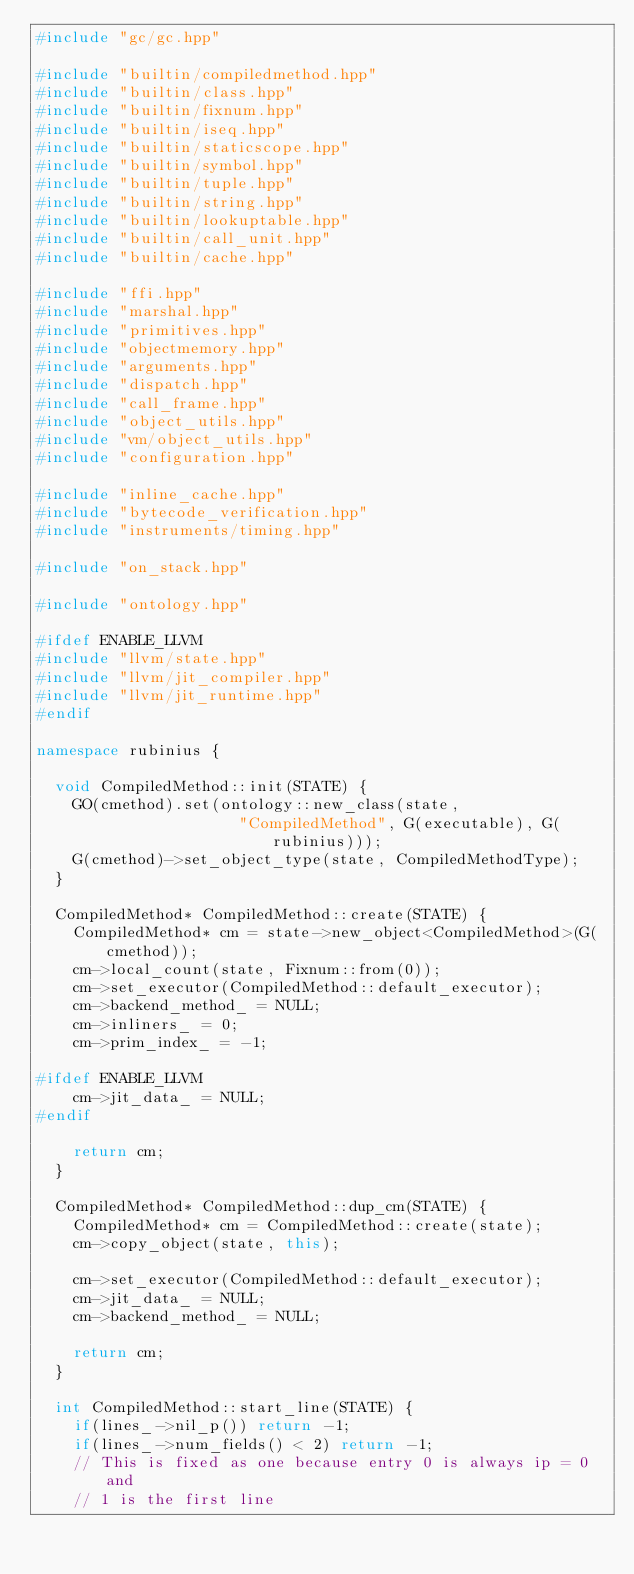<code> <loc_0><loc_0><loc_500><loc_500><_C++_>#include "gc/gc.hpp"

#include "builtin/compiledmethod.hpp"
#include "builtin/class.hpp"
#include "builtin/fixnum.hpp"
#include "builtin/iseq.hpp"
#include "builtin/staticscope.hpp"
#include "builtin/symbol.hpp"
#include "builtin/tuple.hpp"
#include "builtin/string.hpp"
#include "builtin/lookuptable.hpp"
#include "builtin/call_unit.hpp"
#include "builtin/cache.hpp"

#include "ffi.hpp"
#include "marshal.hpp"
#include "primitives.hpp"
#include "objectmemory.hpp"
#include "arguments.hpp"
#include "dispatch.hpp"
#include "call_frame.hpp"
#include "object_utils.hpp"
#include "vm/object_utils.hpp"
#include "configuration.hpp"

#include "inline_cache.hpp"
#include "bytecode_verification.hpp"
#include "instruments/timing.hpp"

#include "on_stack.hpp"

#include "ontology.hpp"

#ifdef ENABLE_LLVM
#include "llvm/state.hpp"
#include "llvm/jit_compiler.hpp"
#include "llvm/jit_runtime.hpp"
#endif

namespace rubinius {

  void CompiledMethod::init(STATE) {
    GO(cmethod).set(ontology::new_class(state,
                      "CompiledMethod", G(executable), G(rubinius)));
    G(cmethod)->set_object_type(state, CompiledMethodType);
  }

  CompiledMethod* CompiledMethod::create(STATE) {
    CompiledMethod* cm = state->new_object<CompiledMethod>(G(cmethod));
    cm->local_count(state, Fixnum::from(0));
    cm->set_executor(CompiledMethod::default_executor);
    cm->backend_method_ = NULL;
    cm->inliners_ = 0;
    cm->prim_index_ = -1;

#ifdef ENABLE_LLVM
    cm->jit_data_ = NULL;
#endif

    return cm;
  }

  CompiledMethod* CompiledMethod::dup_cm(STATE) {
    CompiledMethod* cm = CompiledMethod::create(state);
    cm->copy_object(state, this);

    cm->set_executor(CompiledMethod::default_executor);
    cm->jit_data_ = NULL;
    cm->backend_method_ = NULL;

    return cm;
  }

  int CompiledMethod::start_line(STATE) {
    if(lines_->nil_p()) return -1;
    if(lines_->num_fields() < 2) return -1;
    // This is fixed as one because entry 0 is always ip = 0 and
    // 1 is the first line</code> 